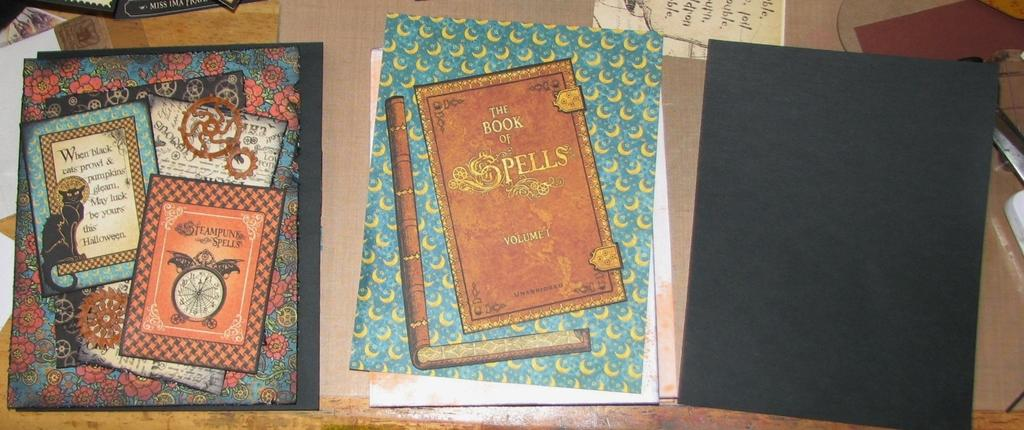<image>
Offer a succinct explanation of the picture presented. A number of books are on a table including the book of spells. 